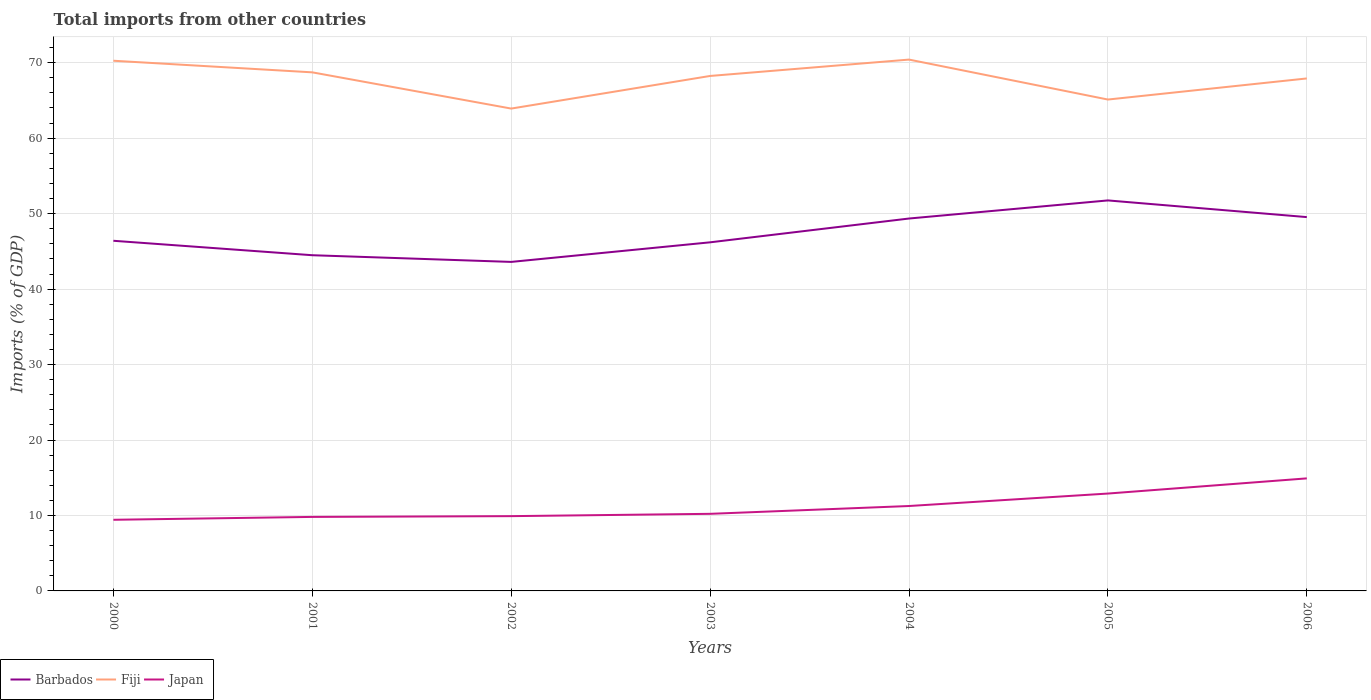How many different coloured lines are there?
Offer a very short reply. 3. Does the line corresponding to Fiji intersect with the line corresponding to Japan?
Keep it short and to the point. No. Across all years, what is the maximum total imports in Fiji?
Keep it short and to the point. 63.92. What is the total total imports in Barbados in the graph?
Keep it short and to the point. -5.05. What is the difference between the highest and the second highest total imports in Barbados?
Your answer should be very brief. 8.15. Is the total imports in Barbados strictly greater than the total imports in Japan over the years?
Make the answer very short. No. How many lines are there?
Give a very brief answer. 3. How many years are there in the graph?
Offer a very short reply. 7. What is the difference between two consecutive major ticks on the Y-axis?
Offer a very short reply. 10. Does the graph contain any zero values?
Make the answer very short. No. Does the graph contain grids?
Your answer should be very brief. Yes. Where does the legend appear in the graph?
Give a very brief answer. Bottom left. What is the title of the graph?
Your answer should be very brief. Total imports from other countries. What is the label or title of the X-axis?
Offer a terse response. Years. What is the label or title of the Y-axis?
Your answer should be very brief. Imports (% of GDP). What is the Imports (% of GDP) in Barbados in 2000?
Your answer should be very brief. 46.4. What is the Imports (% of GDP) in Fiji in 2000?
Offer a terse response. 70.26. What is the Imports (% of GDP) in Japan in 2000?
Offer a very short reply. 9.43. What is the Imports (% of GDP) in Barbados in 2001?
Keep it short and to the point. 44.49. What is the Imports (% of GDP) of Fiji in 2001?
Provide a short and direct response. 68.73. What is the Imports (% of GDP) of Japan in 2001?
Keep it short and to the point. 9.81. What is the Imports (% of GDP) in Barbados in 2002?
Provide a short and direct response. 43.6. What is the Imports (% of GDP) of Fiji in 2002?
Your answer should be very brief. 63.92. What is the Imports (% of GDP) in Japan in 2002?
Your answer should be compact. 9.91. What is the Imports (% of GDP) of Barbados in 2003?
Your response must be concise. 46.2. What is the Imports (% of GDP) in Fiji in 2003?
Give a very brief answer. 68.25. What is the Imports (% of GDP) of Japan in 2003?
Offer a terse response. 10.22. What is the Imports (% of GDP) in Barbados in 2004?
Your answer should be very brief. 49.35. What is the Imports (% of GDP) of Fiji in 2004?
Provide a succinct answer. 70.42. What is the Imports (% of GDP) in Japan in 2004?
Offer a terse response. 11.25. What is the Imports (% of GDP) in Barbados in 2005?
Your answer should be very brief. 51.75. What is the Imports (% of GDP) of Fiji in 2005?
Ensure brevity in your answer.  65.12. What is the Imports (% of GDP) of Japan in 2005?
Offer a terse response. 12.9. What is the Imports (% of GDP) of Barbados in 2006?
Provide a short and direct response. 49.54. What is the Imports (% of GDP) of Fiji in 2006?
Provide a short and direct response. 67.92. What is the Imports (% of GDP) of Japan in 2006?
Make the answer very short. 14.91. Across all years, what is the maximum Imports (% of GDP) in Barbados?
Your answer should be compact. 51.75. Across all years, what is the maximum Imports (% of GDP) in Fiji?
Provide a short and direct response. 70.42. Across all years, what is the maximum Imports (% of GDP) in Japan?
Your answer should be compact. 14.91. Across all years, what is the minimum Imports (% of GDP) in Barbados?
Provide a short and direct response. 43.6. Across all years, what is the minimum Imports (% of GDP) in Fiji?
Your response must be concise. 63.92. Across all years, what is the minimum Imports (% of GDP) in Japan?
Your answer should be compact. 9.43. What is the total Imports (% of GDP) of Barbados in the graph?
Provide a succinct answer. 331.34. What is the total Imports (% of GDP) of Fiji in the graph?
Give a very brief answer. 474.61. What is the total Imports (% of GDP) in Japan in the graph?
Ensure brevity in your answer.  78.44. What is the difference between the Imports (% of GDP) of Barbados in 2000 and that in 2001?
Give a very brief answer. 1.92. What is the difference between the Imports (% of GDP) of Fiji in 2000 and that in 2001?
Make the answer very short. 1.54. What is the difference between the Imports (% of GDP) in Japan in 2000 and that in 2001?
Keep it short and to the point. -0.38. What is the difference between the Imports (% of GDP) of Barbados in 2000 and that in 2002?
Make the answer very short. 2.8. What is the difference between the Imports (% of GDP) of Fiji in 2000 and that in 2002?
Your response must be concise. 6.34. What is the difference between the Imports (% of GDP) in Japan in 2000 and that in 2002?
Offer a very short reply. -0.48. What is the difference between the Imports (% of GDP) in Barbados in 2000 and that in 2003?
Your answer should be compact. 0.21. What is the difference between the Imports (% of GDP) of Fiji in 2000 and that in 2003?
Your answer should be compact. 2.02. What is the difference between the Imports (% of GDP) of Japan in 2000 and that in 2003?
Your response must be concise. -0.79. What is the difference between the Imports (% of GDP) in Barbados in 2000 and that in 2004?
Provide a short and direct response. -2.95. What is the difference between the Imports (% of GDP) of Fiji in 2000 and that in 2004?
Your answer should be compact. -0.15. What is the difference between the Imports (% of GDP) of Japan in 2000 and that in 2004?
Give a very brief answer. -1.82. What is the difference between the Imports (% of GDP) in Barbados in 2000 and that in 2005?
Offer a very short reply. -5.35. What is the difference between the Imports (% of GDP) in Fiji in 2000 and that in 2005?
Ensure brevity in your answer.  5.14. What is the difference between the Imports (% of GDP) of Japan in 2000 and that in 2005?
Offer a very short reply. -3.48. What is the difference between the Imports (% of GDP) of Barbados in 2000 and that in 2006?
Offer a terse response. -3.14. What is the difference between the Imports (% of GDP) of Fiji in 2000 and that in 2006?
Offer a very short reply. 2.35. What is the difference between the Imports (% of GDP) of Japan in 2000 and that in 2006?
Provide a succinct answer. -5.49. What is the difference between the Imports (% of GDP) of Barbados in 2001 and that in 2002?
Offer a very short reply. 0.89. What is the difference between the Imports (% of GDP) in Fiji in 2001 and that in 2002?
Your response must be concise. 4.8. What is the difference between the Imports (% of GDP) of Japan in 2001 and that in 2002?
Provide a short and direct response. -0.1. What is the difference between the Imports (% of GDP) in Barbados in 2001 and that in 2003?
Your response must be concise. -1.71. What is the difference between the Imports (% of GDP) of Fiji in 2001 and that in 2003?
Your answer should be very brief. 0.48. What is the difference between the Imports (% of GDP) of Japan in 2001 and that in 2003?
Your answer should be very brief. -0.41. What is the difference between the Imports (% of GDP) in Barbados in 2001 and that in 2004?
Give a very brief answer. -4.86. What is the difference between the Imports (% of GDP) in Fiji in 2001 and that in 2004?
Give a very brief answer. -1.69. What is the difference between the Imports (% of GDP) of Japan in 2001 and that in 2004?
Ensure brevity in your answer.  -1.44. What is the difference between the Imports (% of GDP) of Barbados in 2001 and that in 2005?
Keep it short and to the point. -7.26. What is the difference between the Imports (% of GDP) in Fiji in 2001 and that in 2005?
Your answer should be compact. 3.6. What is the difference between the Imports (% of GDP) in Japan in 2001 and that in 2005?
Ensure brevity in your answer.  -3.1. What is the difference between the Imports (% of GDP) in Barbados in 2001 and that in 2006?
Provide a short and direct response. -5.05. What is the difference between the Imports (% of GDP) of Fiji in 2001 and that in 2006?
Keep it short and to the point. 0.81. What is the difference between the Imports (% of GDP) of Japan in 2001 and that in 2006?
Make the answer very short. -5.11. What is the difference between the Imports (% of GDP) of Barbados in 2002 and that in 2003?
Offer a terse response. -2.6. What is the difference between the Imports (% of GDP) in Fiji in 2002 and that in 2003?
Make the answer very short. -4.32. What is the difference between the Imports (% of GDP) of Japan in 2002 and that in 2003?
Offer a terse response. -0.31. What is the difference between the Imports (% of GDP) of Barbados in 2002 and that in 2004?
Give a very brief answer. -5.75. What is the difference between the Imports (% of GDP) of Fiji in 2002 and that in 2004?
Offer a very short reply. -6.49. What is the difference between the Imports (% of GDP) of Japan in 2002 and that in 2004?
Your response must be concise. -1.34. What is the difference between the Imports (% of GDP) of Barbados in 2002 and that in 2005?
Keep it short and to the point. -8.15. What is the difference between the Imports (% of GDP) in Fiji in 2002 and that in 2005?
Give a very brief answer. -1.2. What is the difference between the Imports (% of GDP) of Japan in 2002 and that in 2005?
Ensure brevity in your answer.  -2.99. What is the difference between the Imports (% of GDP) of Barbados in 2002 and that in 2006?
Make the answer very short. -5.94. What is the difference between the Imports (% of GDP) in Fiji in 2002 and that in 2006?
Your response must be concise. -3.99. What is the difference between the Imports (% of GDP) of Japan in 2002 and that in 2006?
Ensure brevity in your answer.  -5. What is the difference between the Imports (% of GDP) of Barbados in 2003 and that in 2004?
Keep it short and to the point. -3.15. What is the difference between the Imports (% of GDP) in Fiji in 2003 and that in 2004?
Your answer should be very brief. -2.17. What is the difference between the Imports (% of GDP) of Japan in 2003 and that in 2004?
Ensure brevity in your answer.  -1.04. What is the difference between the Imports (% of GDP) in Barbados in 2003 and that in 2005?
Your response must be concise. -5.55. What is the difference between the Imports (% of GDP) of Fiji in 2003 and that in 2005?
Provide a succinct answer. 3.13. What is the difference between the Imports (% of GDP) of Japan in 2003 and that in 2005?
Your answer should be compact. -2.69. What is the difference between the Imports (% of GDP) in Barbados in 2003 and that in 2006?
Provide a short and direct response. -3.34. What is the difference between the Imports (% of GDP) of Fiji in 2003 and that in 2006?
Offer a terse response. 0.33. What is the difference between the Imports (% of GDP) of Japan in 2003 and that in 2006?
Make the answer very short. -4.7. What is the difference between the Imports (% of GDP) in Barbados in 2004 and that in 2005?
Provide a succinct answer. -2.4. What is the difference between the Imports (% of GDP) in Fiji in 2004 and that in 2005?
Offer a very short reply. 5.3. What is the difference between the Imports (% of GDP) in Japan in 2004 and that in 2005?
Make the answer very short. -1.65. What is the difference between the Imports (% of GDP) in Barbados in 2004 and that in 2006?
Provide a short and direct response. -0.19. What is the difference between the Imports (% of GDP) in Fiji in 2004 and that in 2006?
Your answer should be very brief. 2.5. What is the difference between the Imports (% of GDP) in Japan in 2004 and that in 2006?
Make the answer very short. -3.66. What is the difference between the Imports (% of GDP) of Barbados in 2005 and that in 2006?
Your answer should be very brief. 2.21. What is the difference between the Imports (% of GDP) in Fiji in 2005 and that in 2006?
Your response must be concise. -2.8. What is the difference between the Imports (% of GDP) in Japan in 2005 and that in 2006?
Your answer should be compact. -2.01. What is the difference between the Imports (% of GDP) of Barbados in 2000 and the Imports (% of GDP) of Fiji in 2001?
Offer a terse response. -22.32. What is the difference between the Imports (% of GDP) of Barbados in 2000 and the Imports (% of GDP) of Japan in 2001?
Your answer should be very brief. 36.59. What is the difference between the Imports (% of GDP) of Fiji in 2000 and the Imports (% of GDP) of Japan in 2001?
Make the answer very short. 60.45. What is the difference between the Imports (% of GDP) in Barbados in 2000 and the Imports (% of GDP) in Fiji in 2002?
Your response must be concise. -17.52. What is the difference between the Imports (% of GDP) of Barbados in 2000 and the Imports (% of GDP) of Japan in 2002?
Make the answer very short. 36.49. What is the difference between the Imports (% of GDP) of Fiji in 2000 and the Imports (% of GDP) of Japan in 2002?
Ensure brevity in your answer.  60.35. What is the difference between the Imports (% of GDP) of Barbados in 2000 and the Imports (% of GDP) of Fiji in 2003?
Offer a terse response. -21.84. What is the difference between the Imports (% of GDP) of Barbados in 2000 and the Imports (% of GDP) of Japan in 2003?
Offer a terse response. 36.19. What is the difference between the Imports (% of GDP) in Fiji in 2000 and the Imports (% of GDP) in Japan in 2003?
Offer a terse response. 60.05. What is the difference between the Imports (% of GDP) of Barbados in 2000 and the Imports (% of GDP) of Fiji in 2004?
Ensure brevity in your answer.  -24.01. What is the difference between the Imports (% of GDP) in Barbados in 2000 and the Imports (% of GDP) in Japan in 2004?
Provide a succinct answer. 35.15. What is the difference between the Imports (% of GDP) in Fiji in 2000 and the Imports (% of GDP) in Japan in 2004?
Your answer should be very brief. 59.01. What is the difference between the Imports (% of GDP) of Barbados in 2000 and the Imports (% of GDP) of Fiji in 2005?
Offer a very short reply. -18.72. What is the difference between the Imports (% of GDP) in Barbados in 2000 and the Imports (% of GDP) in Japan in 2005?
Keep it short and to the point. 33.5. What is the difference between the Imports (% of GDP) of Fiji in 2000 and the Imports (% of GDP) of Japan in 2005?
Provide a short and direct response. 57.36. What is the difference between the Imports (% of GDP) of Barbados in 2000 and the Imports (% of GDP) of Fiji in 2006?
Provide a succinct answer. -21.51. What is the difference between the Imports (% of GDP) in Barbados in 2000 and the Imports (% of GDP) in Japan in 2006?
Provide a short and direct response. 31.49. What is the difference between the Imports (% of GDP) of Fiji in 2000 and the Imports (% of GDP) of Japan in 2006?
Offer a very short reply. 55.35. What is the difference between the Imports (% of GDP) of Barbados in 2001 and the Imports (% of GDP) of Fiji in 2002?
Your answer should be very brief. -19.43. What is the difference between the Imports (% of GDP) in Barbados in 2001 and the Imports (% of GDP) in Japan in 2002?
Make the answer very short. 34.58. What is the difference between the Imports (% of GDP) in Fiji in 2001 and the Imports (% of GDP) in Japan in 2002?
Your answer should be very brief. 58.81. What is the difference between the Imports (% of GDP) of Barbados in 2001 and the Imports (% of GDP) of Fiji in 2003?
Provide a short and direct response. -23.76. What is the difference between the Imports (% of GDP) of Barbados in 2001 and the Imports (% of GDP) of Japan in 2003?
Your response must be concise. 34.27. What is the difference between the Imports (% of GDP) of Fiji in 2001 and the Imports (% of GDP) of Japan in 2003?
Make the answer very short. 58.51. What is the difference between the Imports (% of GDP) in Barbados in 2001 and the Imports (% of GDP) in Fiji in 2004?
Provide a succinct answer. -25.93. What is the difference between the Imports (% of GDP) in Barbados in 2001 and the Imports (% of GDP) in Japan in 2004?
Ensure brevity in your answer.  33.24. What is the difference between the Imports (% of GDP) of Fiji in 2001 and the Imports (% of GDP) of Japan in 2004?
Ensure brevity in your answer.  57.47. What is the difference between the Imports (% of GDP) of Barbados in 2001 and the Imports (% of GDP) of Fiji in 2005?
Ensure brevity in your answer.  -20.63. What is the difference between the Imports (% of GDP) in Barbados in 2001 and the Imports (% of GDP) in Japan in 2005?
Provide a succinct answer. 31.58. What is the difference between the Imports (% of GDP) in Fiji in 2001 and the Imports (% of GDP) in Japan in 2005?
Ensure brevity in your answer.  55.82. What is the difference between the Imports (% of GDP) of Barbados in 2001 and the Imports (% of GDP) of Fiji in 2006?
Your response must be concise. -23.43. What is the difference between the Imports (% of GDP) in Barbados in 2001 and the Imports (% of GDP) in Japan in 2006?
Give a very brief answer. 29.57. What is the difference between the Imports (% of GDP) of Fiji in 2001 and the Imports (% of GDP) of Japan in 2006?
Your answer should be compact. 53.81. What is the difference between the Imports (% of GDP) of Barbados in 2002 and the Imports (% of GDP) of Fiji in 2003?
Your answer should be compact. -24.64. What is the difference between the Imports (% of GDP) of Barbados in 2002 and the Imports (% of GDP) of Japan in 2003?
Make the answer very short. 33.39. What is the difference between the Imports (% of GDP) of Fiji in 2002 and the Imports (% of GDP) of Japan in 2003?
Make the answer very short. 53.71. What is the difference between the Imports (% of GDP) of Barbados in 2002 and the Imports (% of GDP) of Fiji in 2004?
Keep it short and to the point. -26.81. What is the difference between the Imports (% of GDP) in Barbados in 2002 and the Imports (% of GDP) in Japan in 2004?
Provide a succinct answer. 32.35. What is the difference between the Imports (% of GDP) in Fiji in 2002 and the Imports (% of GDP) in Japan in 2004?
Make the answer very short. 52.67. What is the difference between the Imports (% of GDP) of Barbados in 2002 and the Imports (% of GDP) of Fiji in 2005?
Provide a short and direct response. -21.52. What is the difference between the Imports (% of GDP) in Barbados in 2002 and the Imports (% of GDP) in Japan in 2005?
Keep it short and to the point. 30.7. What is the difference between the Imports (% of GDP) in Fiji in 2002 and the Imports (% of GDP) in Japan in 2005?
Your response must be concise. 51.02. What is the difference between the Imports (% of GDP) of Barbados in 2002 and the Imports (% of GDP) of Fiji in 2006?
Offer a terse response. -24.31. What is the difference between the Imports (% of GDP) in Barbados in 2002 and the Imports (% of GDP) in Japan in 2006?
Offer a very short reply. 28.69. What is the difference between the Imports (% of GDP) of Fiji in 2002 and the Imports (% of GDP) of Japan in 2006?
Provide a succinct answer. 49.01. What is the difference between the Imports (% of GDP) in Barbados in 2003 and the Imports (% of GDP) in Fiji in 2004?
Provide a succinct answer. -24.22. What is the difference between the Imports (% of GDP) in Barbados in 2003 and the Imports (% of GDP) in Japan in 2004?
Offer a very short reply. 34.95. What is the difference between the Imports (% of GDP) in Fiji in 2003 and the Imports (% of GDP) in Japan in 2004?
Offer a very short reply. 56.99. What is the difference between the Imports (% of GDP) of Barbados in 2003 and the Imports (% of GDP) of Fiji in 2005?
Keep it short and to the point. -18.92. What is the difference between the Imports (% of GDP) in Barbados in 2003 and the Imports (% of GDP) in Japan in 2005?
Provide a short and direct response. 33.29. What is the difference between the Imports (% of GDP) in Fiji in 2003 and the Imports (% of GDP) in Japan in 2005?
Your answer should be very brief. 55.34. What is the difference between the Imports (% of GDP) of Barbados in 2003 and the Imports (% of GDP) of Fiji in 2006?
Give a very brief answer. -21.72. What is the difference between the Imports (% of GDP) of Barbados in 2003 and the Imports (% of GDP) of Japan in 2006?
Offer a terse response. 31.28. What is the difference between the Imports (% of GDP) in Fiji in 2003 and the Imports (% of GDP) in Japan in 2006?
Ensure brevity in your answer.  53.33. What is the difference between the Imports (% of GDP) in Barbados in 2004 and the Imports (% of GDP) in Fiji in 2005?
Offer a terse response. -15.77. What is the difference between the Imports (% of GDP) in Barbados in 2004 and the Imports (% of GDP) in Japan in 2005?
Your answer should be compact. 36.45. What is the difference between the Imports (% of GDP) in Fiji in 2004 and the Imports (% of GDP) in Japan in 2005?
Make the answer very short. 57.51. What is the difference between the Imports (% of GDP) of Barbados in 2004 and the Imports (% of GDP) of Fiji in 2006?
Ensure brevity in your answer.  -18.56. What is the difference between the Imports (% of GDP) of Barbados in 2004 and the Imports (% of GDP) of Japan in 2006?
Offer a terse response. 34.44. What is the difference between the Imports (% of GDP) of Fiji in 2004 and the Imports (% of GDP) of Japan in 2006?
Keep it short and to the point. 55.5. What is the difference between the Imports (% of GDP) in Barbados in 2005 and the Imports (% of GDP) in Fiji in 2006?
Your answer should be very brief. -16.17. What is the difference between the Imports (% of GDP) of Barbados in 2005 and the Imports (% of GDP) of Japan in 2006?
Make the answer very short. 36.84. What is the difference between the Imports (% of GDP) in Fiji in 2005 and the Imports (% of GDP) in Japan in 2006?
Offer a very short reply. 50.21. What is the average Imports (% of GDP) in Barbados per year?
Ensure brevity in your answer.  47.33. What is the average Imports (% of GDP) in Fiji per year?
Ensure brevity in your answer.  67.8. What is the average Imports (% of GDP) in Japan per year?
Give a very brief answer. 11.21. In the year 2000, what is the difference between the Imports (% of GDP) in Barbados and Imports (% of GDP) in Fiji?
Provide a short and direct response. -23.86. In the year 2000, what is the difference between the Imports (% of GDP) in Barbados and Imports (% of GDP) in Japan?
Offer a very short reply. 36.98. In the year 2000, what is the difference between the Imports (% of GDP) of Fiji and Imports (% of GDP) of Japan?
Give a very brief answer. 60.83. In the year 2001, what is the difference between the Imports (% of GDP) in Barbados and Imports (% of GDP) in Fiji?
Keep it short and to the point. -24.24. In the year 2001, what is the difference between the Imports (% of GDP) of Barbados and Imports (% of GDP) of Japan?
Provide a short and direct response. 34.68. In the year 2001, what is the difference between the Imports (% of GDP) of Fiji and Imports (% of GDP) of Japan?
Make the answer very short. 58.92. In the year 2002, what is the difference between the Imports (% of GDP) of Barbados and Imports (% of GDP) of Fiji?
Provide a short and direct response. -20.32. In the year 2002, what is the difference between the Imports (% of GDP) in Barbados and Imports (% of GDP) in Japan?
Provide a short and direct response. 33.69. In the year 2002, what is the difference between the Imports (% of GDP) of Fiji and Imports (% of GDP) of Japan?
Provide a succinct answer. 54.01. In the year 2003, what is the difference between the Imports (% of GDP) of Barbados and Imports (% of GDP) of Fiji?
Ensure brevity in your answer.  -22.05. In the year 2003, what is the difference between the Imports (% of GDP) of Barbados and Imports (% of GDP) of Japan?
Provide a succinct answer. 35.98. In the year 2003, what is the difference between the Imports (% of GDP) in Fiji and Imports (% of GDP) in Japan?
Keep it short and to the point. 58.03. In the year 2004, what is the difference between the Imports (% of GDP) of Barbados and Imports (% of GDP) of Fiji?
Keep it short and to the point. -21.06. In the year 2004, what is the difference between the Imports (% of GDP) of Barbados and Imports (% of GDP) of Japan?
Your answer should be very brief. 38.1. In the year 2004, what is the difference between the Imports (% of GDP) in Fiji and Imports (% of GDP) in Japan?
Offer a terse response. 59.16. In the year 2005, what is the difference between the Imports (% of GDP) of Barbados and Imports (% of GDP) of Fiji?
Ensure brevity in your answer.  -13.37. In the year 2005, what is the difference between the Imports (% of GDP) of Barbados and Imports (% of GDP) of Japan?
Make the answer very short. 38.85. In the year 2005, what is the difference between the Imports (% of GDP) of Fiji and Imports (% of GDP) of Japan?
Provide a succinct answer. 52.22. In the year 2006, what is the difference between the Imports (% of GDP) in Barbados and Imports (% of GDP) in Fiji?
Make the answer very short. -18.38. In the year 2006, what is the difference between the Imports (% of GDP) of Barbados and Imports (% of GDP) of Japan?
Make the answer very short. 34.63. In the year 2006, what is the difference between the Imports (% of GDP) in Fiji and Imports (% of GDP) in Japan?
Your response must be concise. 53. What is the ratio of the Imports (% of GDP) in Barbados in 2000 to that in 2001?
Keep it short and to the point. 1.04. What is the ratio of the Imports (% of GDP) in Fiji in 2000 to that in 2001?
Make the answer very short. 1.02. What is the ratio of the Imports (% of GDP) of Japan in 2000 to that in 2001?
Give a very brief answer. 0.96. What is the ratio of the Imports (% of GDP) in Barbados in 2000 to that in 2002?
Provide a short and direct response. 1.06. What is the ratio of the Imports (% of GDP) in Fiji in 2000 to that in 2002?
Offer a terse response. 1.1. What is the ratio of the Imports (% of GDP) in Japan in 2000 to that in 2002?
Offer a terse response. 0.95. What is the ratio of the Imports (% of GDP) of Barbados in 2000 to that in 2003?
Your response must be concise. 1. What is the ratio of the Imports (% of GDP) in Fiji in 2000 to that in 2003?
Give a very brief answer. 1.03. What is the ratio of the Imports (% of GDP) of Japan in 2000 to that in 2003?
Provide a succinct answer. 0.92. What is the ratio of the Imports (% of GDP) of Barbados in 2000 to that in 2004?
Keep it short and to the point. 0.94. What is the ratio of the Imports (% of GDP) of Japan in 2000 to that in 2004?
Your answer should be compact. 0.84. What is the ratio of the Imports (% of GDP) of Barbados in 2000 to that in 2005?
Your answer should be very brief. 0.9. What is the ratio of the Imports (% of GDP) in Fiji in 2000 to that in 2005?
Offer a terse response. 1.08. What is the ratio of the Imports (% of GDP) in Japan in 2000 to that in 2005?
Make the answer very short. 0.73. What is the ratio of the Imports (% of GDP) in Barbados in 2000 to that in 2006?
Keep it short and to the point. 0.94. What is the ratio of the Imports (% of GDP) in Fiji in 2000 to that in 2006?
Your answer should be compact. 1.03. What is the ratio of the Imports (% of GDP) in Japan in 2000 to that in 2006?
Your answer should be very brief. 0.63. What is the ratio of the Imports (% of GDP) of Barbados in 2001 to that in 2002?
Give a very brief answer. 1.02. What is the ratio of the Imports (% of GDP) in Fiji in 2001 to that in 2002?
Ensure brevity in your answer.  1.08. What is the ratio of the Imports (% of GDP) in Japan in 2001 to that in 2003?
Offer a terse response. 0.96. What is the ratio of the Imports (% of GDP) in Barbados in 2001 to that in 2004?
Offer a terse response. 0.9. What is the ratio of the Imports (% of GDP) of Fiji in 2001 to that in 2004?
Your answer should be compact. 0.98. What is the ratio of the Imports (% of GDP) of Japan in 2001 to that in 2004?
Provide a short and direct response. 0.87. What is the ratio of the Imports (% of GDP) of Barbados in 2001 to that in 2005?
Provide a succinct answer. 0.86. What is the ratio of the Imports (% of GDP) in Fiji in 2001 to that in 2005?
Provide a short and direct response. 1.06. What is the ratio of the Imports (% of GDP) of Japan in 2001 to that in 2005?
Give a very brief answer. 0.76. What is the ratio of the Imports (% of GDP) in Barbados in 2001 to that in 2006?
Offer a terse response. 0.9. What is the ratio of the Imports (% of GDP) of Fiji in 2001 to that in 2006?
Keep it short and to the point. 1.01. What is the ratio of the Imports (% of GDP) of Japan in 2001 to that in 2006?
Offer a terse response. 0.66. What is the ratio of the Imports (% of GDP) of Barbados in 2002 to that in 2003?
Provide a short and direct response. 0.94. What is the ratio of the Imports (% of GDP) of Fiji in 2002 to that in 2003?
Keep it short and to the point. 0.94. What is the ratio of the Imports (% of GDP) in Barbados in 2002 to that in 2004?
Give a very brief answer. 0.88. What is the ratio of the Imports (% of GDP) in Fiji in 2002 to that in 2004?
Keep it short and to the point. 0.91. What is the ratio of the Imports (% of GDP) of Japan in 2002 to that in 2004?
Provide a short and direct response. 0.88. What is the ratio of the Imports (% of GDP) in Barbados in 2002 to that in 2005?
Your answer should be compact. 0.84. What is the ratio of the Imports (% of GDP) of Fiji in 2002 to that in 2005?
Offer a very short reply. 0.98. What is the ratio of the Imports (% of GDP) of Japan in 2002 to that in 2005?
Make the answer very short. 0.77. What is the ratio of the Imports (% of GDP) in Barbados in 2002 to that in 2006?
Offer a terse response. 0.88. What is the ratio of the Imports (% of GDP) in Japan in 2002 to that in 2006?
Provide a short and direct response. 0.66. What is the ratio of the Imports (% of GDP) in Barbados in 2003 to that in 2004?
Provide a short and direct response. 0.94. What is the ratio of the Imports (% of GDP) of Fiji in 2003 to that in 2004?
Your response must be concise. 0.97. What is the ratio of the Imports (% of GDP) of Japan in 2003 to that in 2004?
Provide a succinct answer. 0.91. What is the ratio of the Imports (% of GDP) in Barbados in 2003 to that in 2005?
Your response must be concise. 0.89. What is the ratio of the Imports (% of GDP) of Fiji in 2003 to that in 2005?
Make the answer very short. 1.05. What is the ratio of the Imports (% of GDP) of Japan in 2003 to that in 2005?
Your answer should be compact. 0.79. What is the ratio of the Imports (% of GDP) of Barbados in 2003 to that in 2006?
Your answer should be very brief. 0.93. What is the ratio of the Imports (% of GDP) of Japan in 2003 to that in 2006?
Give a very brief answer. 0.69. What is the ratio of the Imports (% of GDP) of Barbados in 2004 to that in 2005?
Ensure brevity in your answer.  0.95. What is the ratio of the Imports (% of GDP) in Fiji in 2004 to that in 2005?
Provide a short and direct response. 1.08. What is the ratio of the Imports (% of GDP) in Japan in 2004 to that in 2005?
Provide a succinct answer. 0.87. What is the ratio of the Imports (% of GDP) in Fiji in 2004 to that in 2006?
Provide a succinct answer. 1.04. What is the ratio of the Imports (% of GDP) of Japan in 2004 to that in 2006?
Offer a very short reply. 0.75. What is the ratio of the Imports (% of GDP) in Barbados in 2005 to that in 2006?
Ensure brevity in your answer.  1.04. What is the ratio of the Imports (% of GDP) in Fiji in 2005 to that in 2006?
Provide a short and direct response. 0.96. What is the ratio of the Imports (% of GDP) of Japan in 2005 to that in 2006?
Provide a short and direct response. 0.87. What is the difference between the highest and the second highest Imports (% of GDP) of Barbados?
Provide a short and direct response. 2.21. What is the difference between the highest and the second highest Imports (% of GDP) in Fiji?
Ensure brevity in your answer.  0.15. What is the difference between the highest and the second highest Imports (% of GDP) in Japan?
Make the answer very short. 2.01. What is the difference between the highest and the lowest Imports (% of GDP) in Barbados?
Your answer should be very brief. 8.15. What is the difference between the highest and the lowest Imports (% of GDP) of Fiji?
Your answer should be compact. 6.49. What is the difference between the highest and the lowest Imports (% of GDP) in Japan?
Offer a terse response. 5.49. 